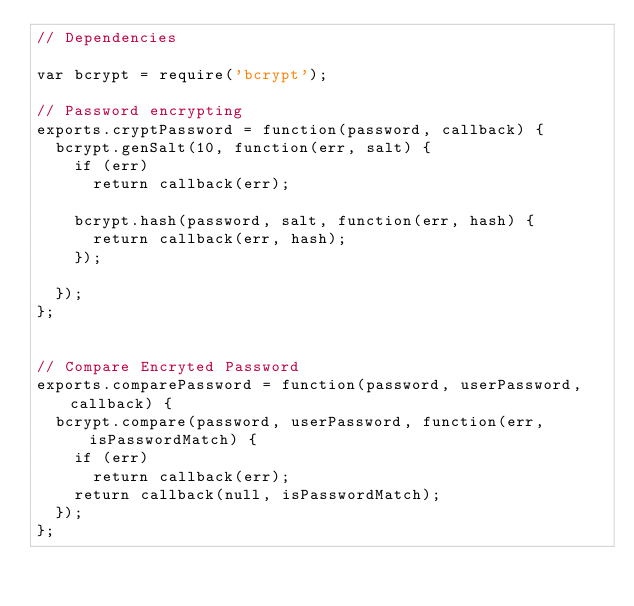<code> <loc_0><loc_0><loc_500><loc_500><_JavaScript_>// Dependencies

var bcrypt = require('bcrypt');

// Password encrypting
exports.cryptPassword = function(password, callback) {
  bcrypt.genSalt(10, function(err, salt) {
    if (err) 
      return callback(err);

    bcrypt.hash(password, salt, function(err, hash) {
      return callback(err, hash);
    });

  });
};


// Compare Encryted Password
exports.comparePassword = function(password, userPassword, callback) {
  bcrypt.compare(password, userPassword, function(err, isPasswordMatch) {
    if (err) 
      return callback(err);
    return callback(null, isPasswordMatch);
  });
};</code> 